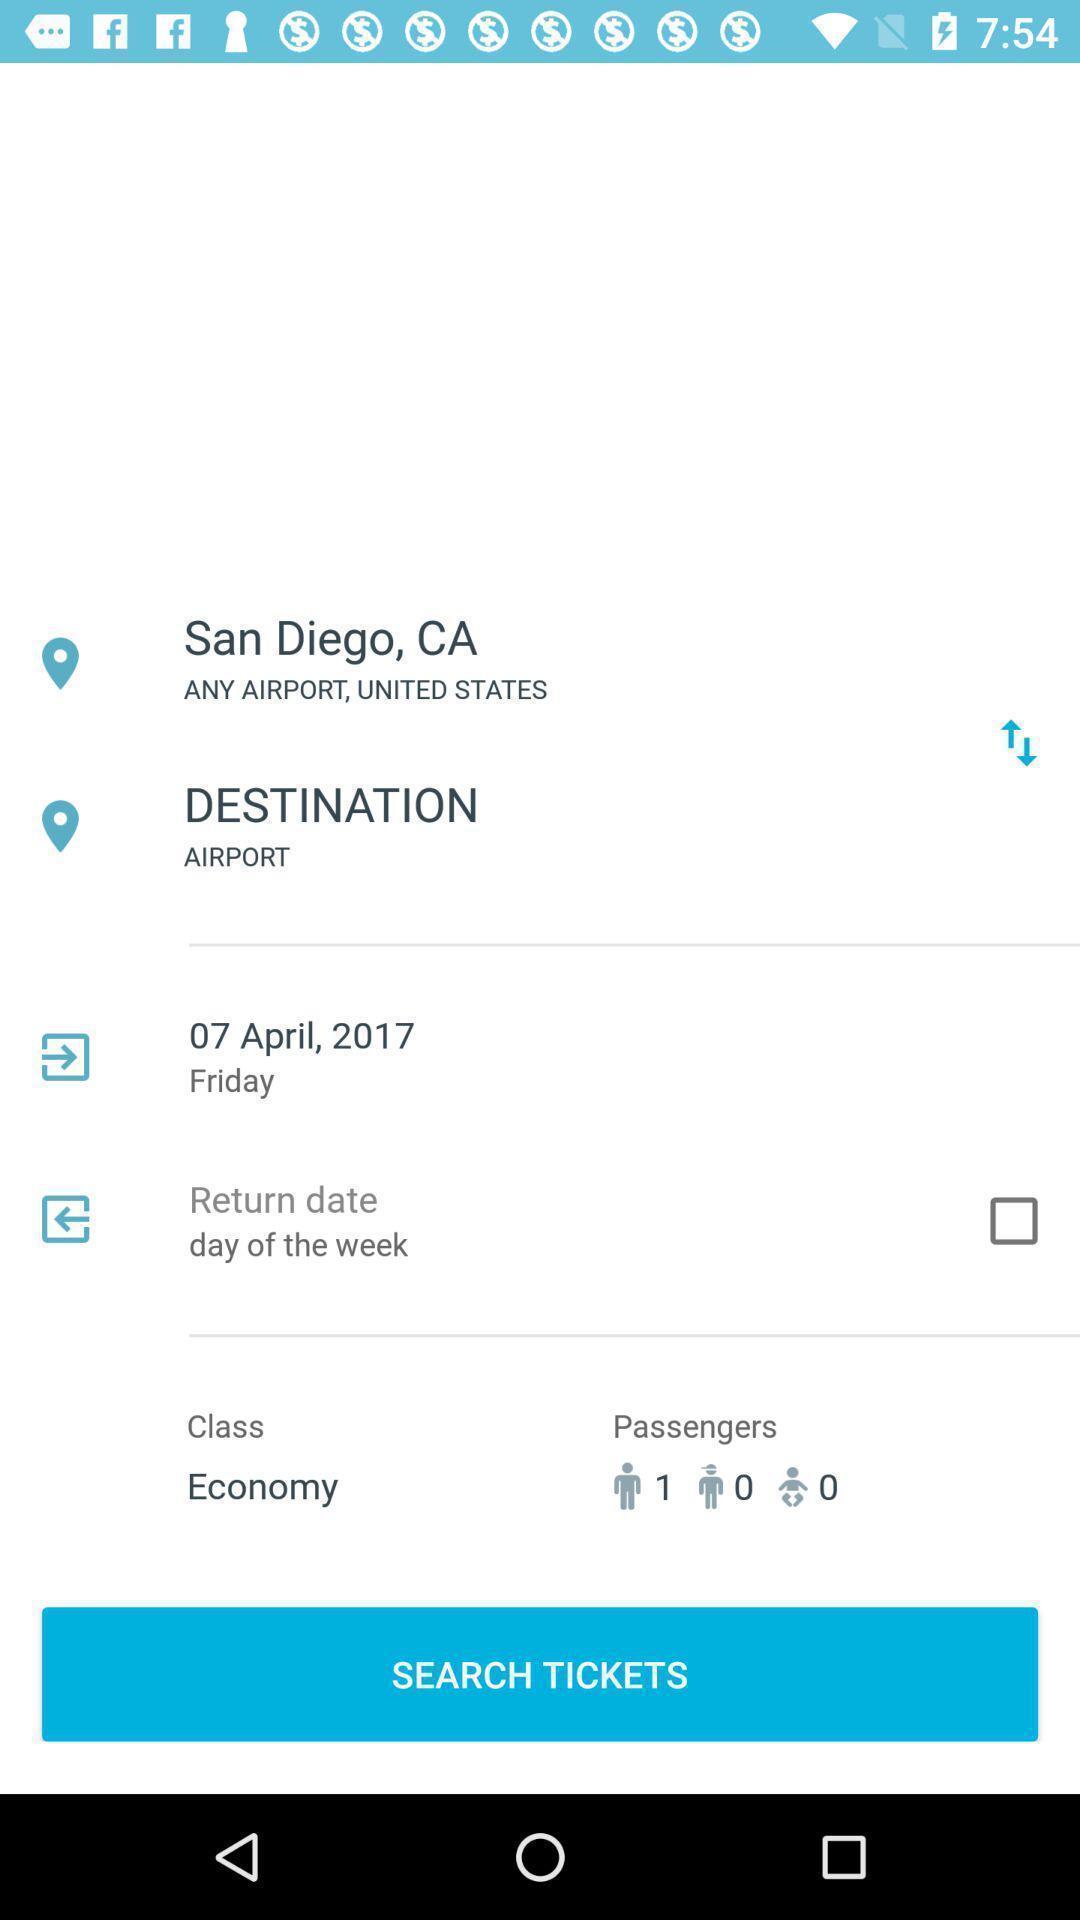Tell me what you see in this picture. Screen showing search bar to find tickets in travel app. 